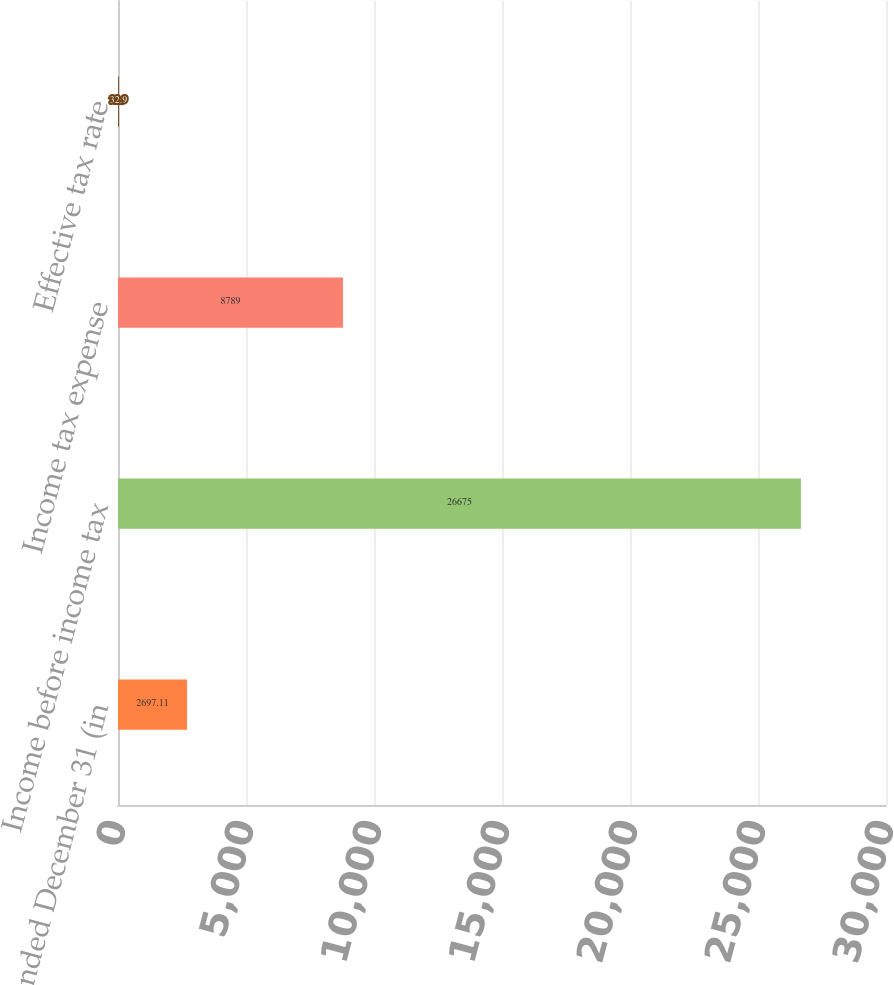Convert chart to OTSL. <chart><loc_0><loc_0><loc_500><loc_500><bar_chart><fcel>Year ended December 31 (in<fcel>Income before income tax<fcel>Income tax expense<fcel>Effective tax rate<nl><fcel>2697.11<fcel>26675<fcel>8789<fcel>32.9<nl></chart> 